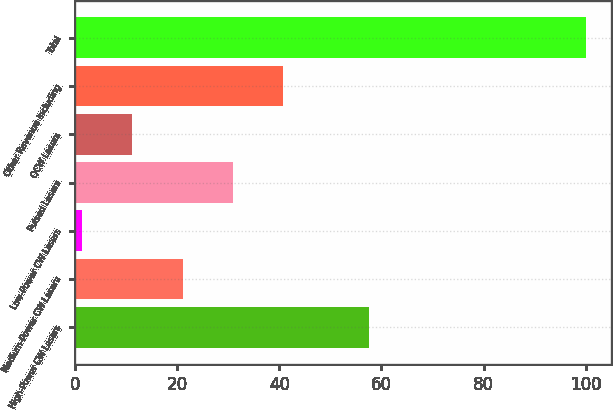<chart> <loc_0><loc_0><loc_500><loc_500><bar_chart><fcel>High-Power CW Lasers<fcel>Medium-Power CW Lasers<fcel>Low-Power CW Lasers<fcel>Pulsed Lasers<fcel>QCW Lasers<fcel>Other Revenue including<fcel>Total<nl><fcel>57.5<fcel>21.04<fcel>1.3<fcel>30.91<fcel>11.17<fcel>40.78<fcel>100<nl></chart> 